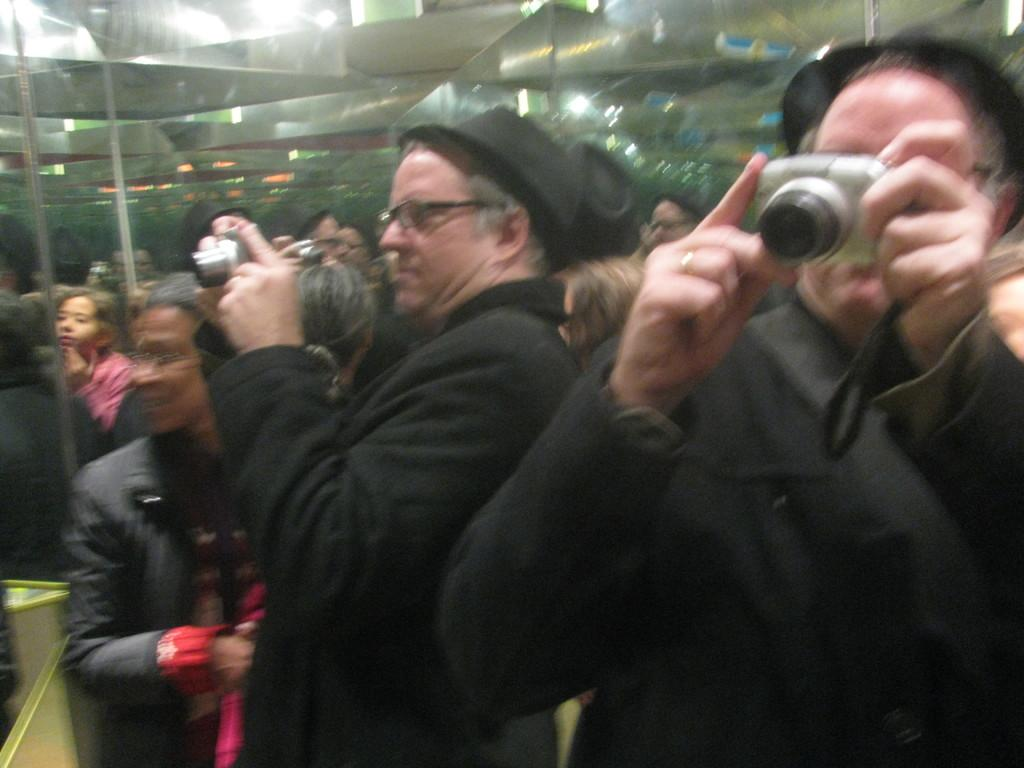What are the people in the image holding? The people in the image are holding a camera in their hands. Can you describe the people in the background of the image? There are people standing in the background of the image. What type of machine is being used to commit a crime in the image? There is no machine or crime present in the image; it only shows people holding a camera and others standing in the background. 